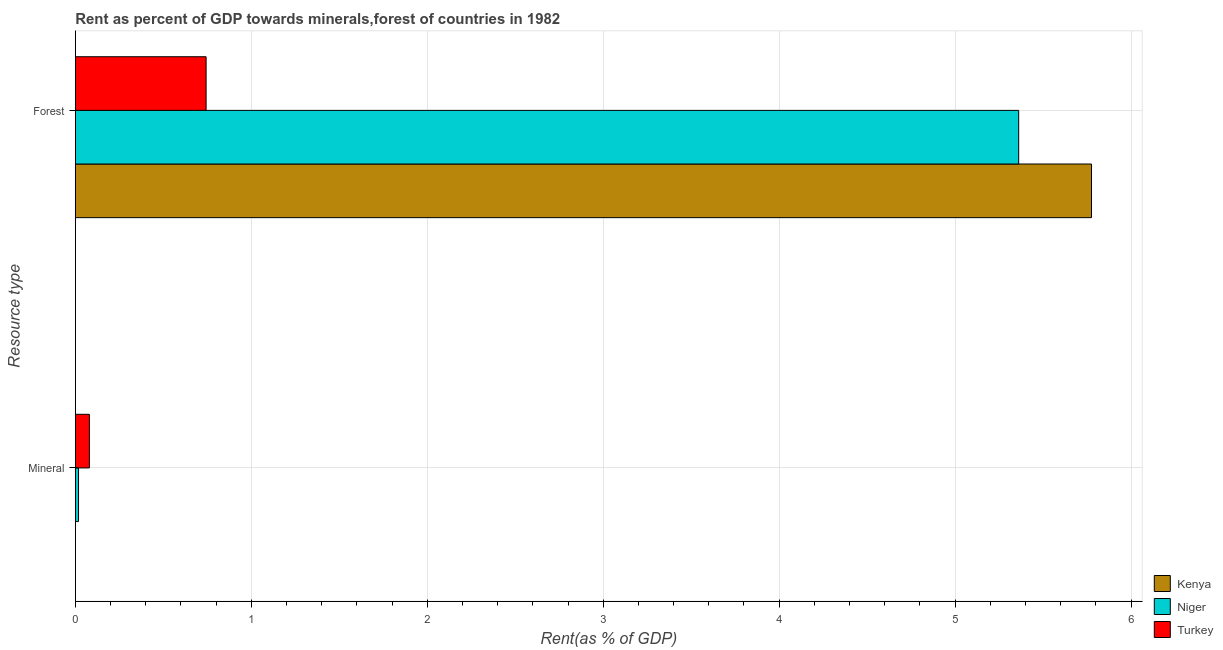How many different coloured bars are there?
Offer a terse response. 3. Are the number of bars on each tick of the Y-axis equal?
Provide a short and direct response. Yes. How many bars are there on the 1st tick from the bottom?
Ensure brevity in your answer.  3. What is the label of the 2nd group of bars from the top?
Make the answer very short. Mineral. What is the forest rent in Turkey?
Your answer should be very brief. 0.74. Across all countries, what is the maximum mineral rent?
Keep it short and to the point. 0.08. Across all countries, what is the minimum forest rent?
Your answer should be compact. 0.74. In which country was the mineral rent minimum?
Give a very brief answer. Kenya. What is the total forest rent in the graph?
Offer a very short reply. 11.88. What is the difference between the mineral rent in Niger and that in Turkey?
Provide a short and direct response. -0.06. What is the difference between the mineral rent in Turkey and the forest rent in Niger?
Offer a very short reply. -5.28. What is the average mineral rent per country?
Offer a terse response. 0.03. What is the difference between the mineral rent and forest rent in Turkey?
Provide a succinct answer. -0.66. In how many countries, is the mineral rent greater than 4.4 %?
Ensure brevity in your answer.  0. What is the ratio of the mineral rent in Niger to that in Turkey?
Your answer should be compact. 0.23. In how many countries, is the mineral rent greater than the average mineral rent taken over all countries?
Give a very brief answer. 1. What does the 3rd bar from the bottom in Mineral represents?
Offer a very short reply. Turkey. How many bars are there?
Your response must be concise. 6. Are all the bars in the graph horizontal?
Keep it short and to the point. Yes. How many countries are there in the graph?
Give a very brief answer. 3. Are the values on the major ticks of X-axis written in scientific E-notation?
Offer a very short reply. No. Does the graph contain grids?
Give a very brief answer. Yes. Where does the legend appear in the graph?
Ensure brevity in your answer.  Bottom right. How many legend labels are there?
Give a very brief answer. 3. What is the title of the graph?
Provide a short and direct response. Rent as percent of GDP towards minerals,forest of countries in 1982. What is the label or title of the X-axis?
Your answer should be compact. Rent(as % of GDP). What is the label or title of the Y-axis?
Provide a succinct answer. Resource type. What is the Rent(as % of GDP) in Kenya in Mineral?
Your answer should be very brief. 6.72101396452568e-5. What is the Rent(as % of GDP) in Niger in Mineral?
Offer a very short reply. 0.02. What is the Rent(as % of GDP) of Turkey in Mineral?
Your answer should be compact. 0.08. What is the Rent(as % of GDP) in Kenya in Forest?
Provide a short and direct response. 5.77. What is the Rent(as % of GDP) in Niger in Forest?
Keep it short and to the point. 5.36. What is the Rent(as % of GDP) of Turkey in Forest?
Your response must be concise. 0.74. Across all Resource type, what is the maximum Rent(as % of GDP) of Kenya?
Your answer should be very brief. 5.77. Across all Resource type, what is the maximum Rent(as % of GDP) of Niger?
Offer a terse response. 5.36. Across all Resource type, what is the maximum Rent(as % of GDP) in Turkey?
Make the answer very short. 0.74. Across all Resource type, what is the minimum Rent(as % of GDP) in Kenya?
Offer a terse response. 6.72101396452568e-5. Across all Resource type, what is the minimum Rent(as % of GDP) in Niger?
Your response must be concise. 0.02. Across all Resource type, what is the minimum Rent(as % of GDP) in Turkey?
Your answer should be very brief. 0.08. What is the total Rent(as % of GDP) of Kenya in the graph?
Ensure brevity in your answer.  5.77. What is the total Rent(as % of GDP) of Niger in the graph?
Ensure brevity in your answer.  5.38. What is the total Rent(as % of GDP) of Turkey in the graph?
Keep it short and to the point. 0.82. What is the difference between the Rent(as % of GDP) of Kenya in Mineral and that in Forest?
Your answer should be compact. -5.77. What is the difference between the Rent(as % of GDP) in Niger in Mineral and that in Forest?
Ensure brevity in your answer.  -5.34. What is the difference between the Rent(as % of GDP) of Turkey in Mineral and that in Forest?
Provide a succinct answer. -0.66. What is the difference between the Rent(as % of GDP) in Kenya in Mineral and the Rent(as % of GDP) in Niger in Forest?
Provide a succinct answer. -5.36. What is the difference between the Rent(as % of GDP) in Kenya in Mineral and the Rent(as % of GDP) in Turkey in Forest?
Keep it short and to the point. -0.74. What is the difference between the Rent(as % of GDP) in Niger in Mineral and the Rent(as % of GDP) in Turkey in Forest?
Your answer should be compact. -0.72. What is the average Rent(as % of GDP) in Kenya per Resource type?
Ensure brevity in your answer.  2.89. What is the average Rent(as % of GDP) of Niger per Resource type?
Your answer should be compact. 2.69. What is the average Rent(as % of GDP) of Turkey per Resource type?
Your response must be concise. 0.41. What is the difference between the Rent(as % of GDP) in Kenya and Rent(as % of GDP) in Niger in Mineral?
Give a very brief answer. -0.02. What is the difference between the Rent(as % of GDP) in Kenya and Rent(as % of GDP) in Turkey in Mineral?
Your answer should be very brief. -0.08. What is the difference between the Rent(as % of GDP) in Niger and Rent(as % of GDP) in Turkey in Mineral?
Your answer should be compact. -0.06. What is the difference between the Rent(as % of GDP) in Kenya and Rent(as % of GDP) in Niger in Forest?
Give a very brief answer. 0.41. What is the difference between the Rent(as % of GDP) in Kenya and Rent(as % of GDP) in Turkey in Forest?
Offer a terse response. 5.03. What is the difference between the Rent(as % of GDP) of Niger and Rent(as % of GDP) of Turkey in Forest?
Give a very brief answer. 4.62. What is the ratio of the Rent(as % of GDP) of Niger in Mineral to that in Forest?
Offer a terse response. 0. What is the ratio of the Rent(as % of GDP) of Turkey in Mineral to that in Forest?
Your answer should be compact. 0.11. What is the difference between the highest and the second highest Rent(as % of GDP) of Kenya?
Offer a very short reply. 5.77. What is the difference between the highest and the second highest Rent(as % of GDP) of Niger?
Your answer should be very brief. 5.34. What is the difference between the highest and the second highest Rent(as % of GDP) of Turkey?
Offer a very short reply. 0.66. What is the difference between the highest and the lowest Rent(as % of GDP) of Kenya?
Give a very brief answer. 5.77. What is the difference between the highest and the lowest Rent(as % of GDP) of Niger?
Ensure brevity in your answer.  5.34. What is the difference between the highest and the lowest Rent(as % of GDP) in Turkey?
Provide a short and direct response. 0.66. 